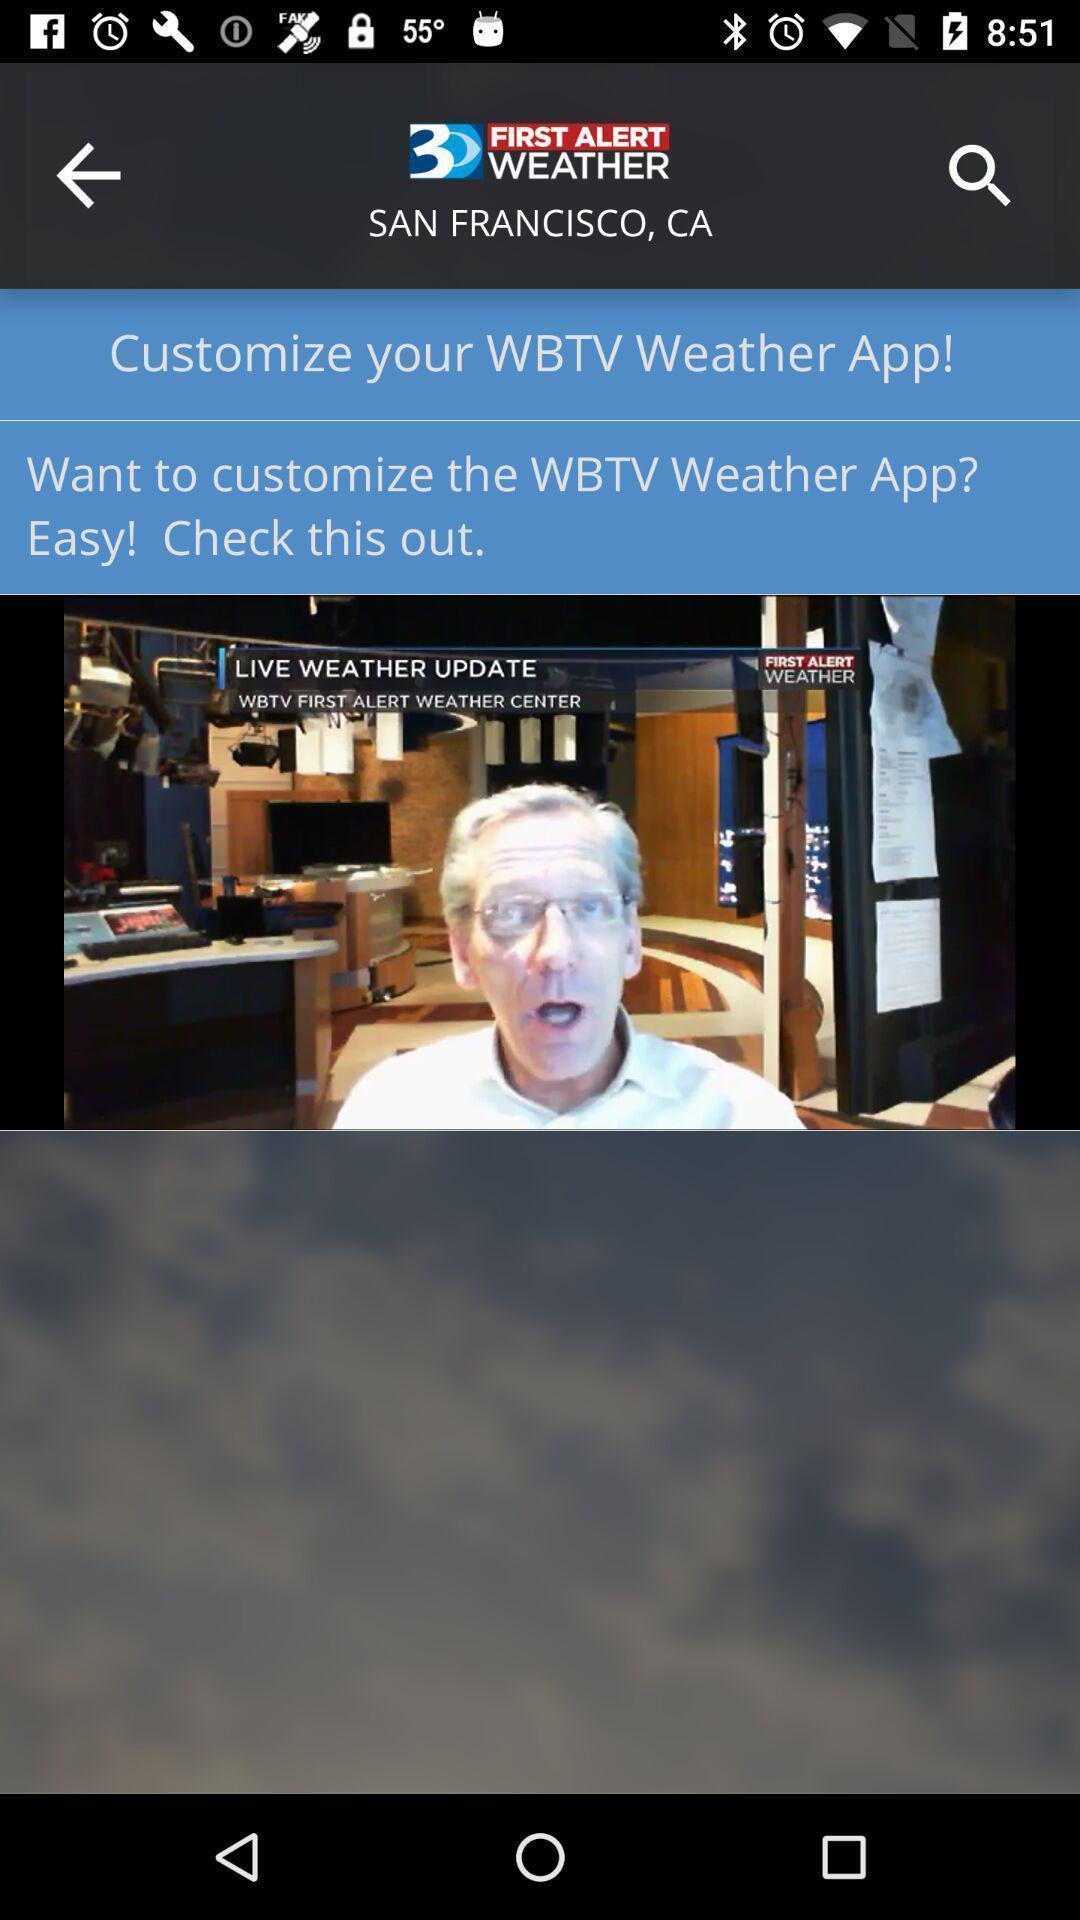Describe the content in this image. Screen shows about weather forecast. 